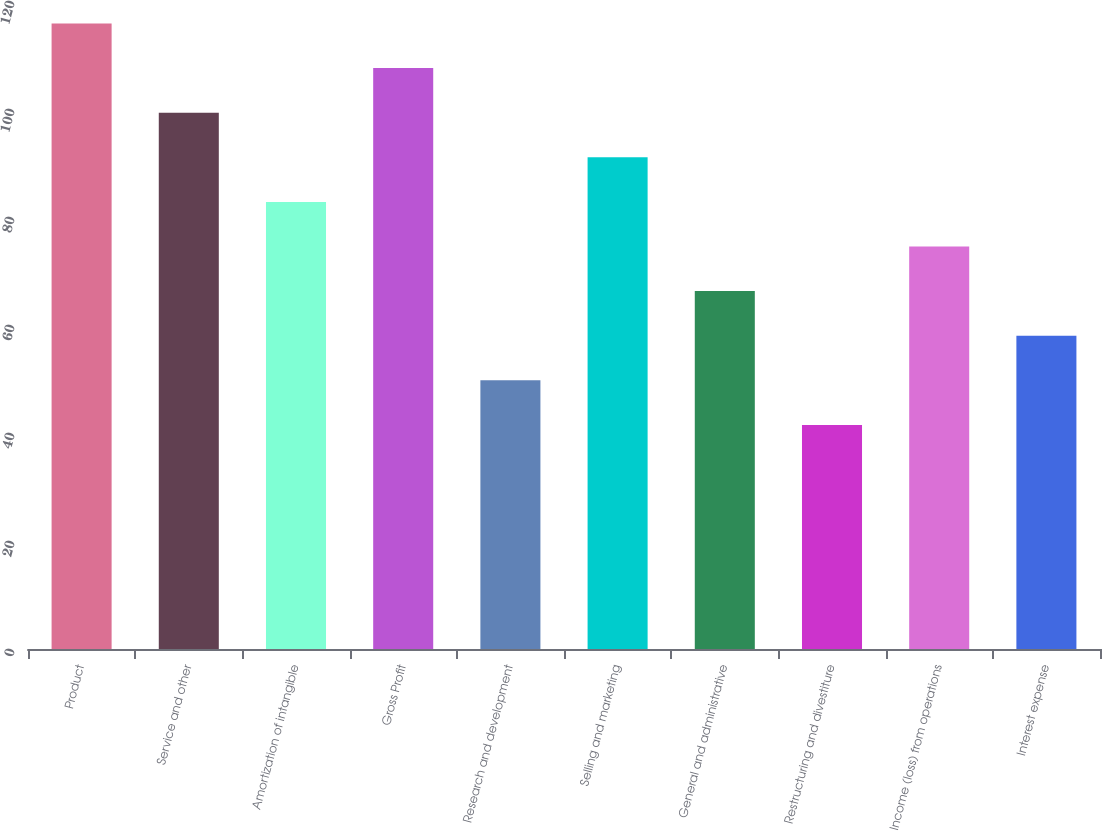<chart> <loc_0><loc_0><loc_500><loc_500><bar_chart><fcel>Product<fcel>Service and other<fcel>Amortization of intangible<fcel>Gross Profit<fcel>Research and development<fcel>Selling and marketing<fcel>General and administrative<fcel>Restructuring and divestiture<fcel>Income (loss) from operations<fcel>Interest expense<nl><fcel>115.84<fcel>99.32<fcel>82.8<fcel>107.58<fcel>49.76<fcel>91.06<fcel>66.28<fcel>41.5<fcel>74.54<fcel>58.02<nl></chart> 